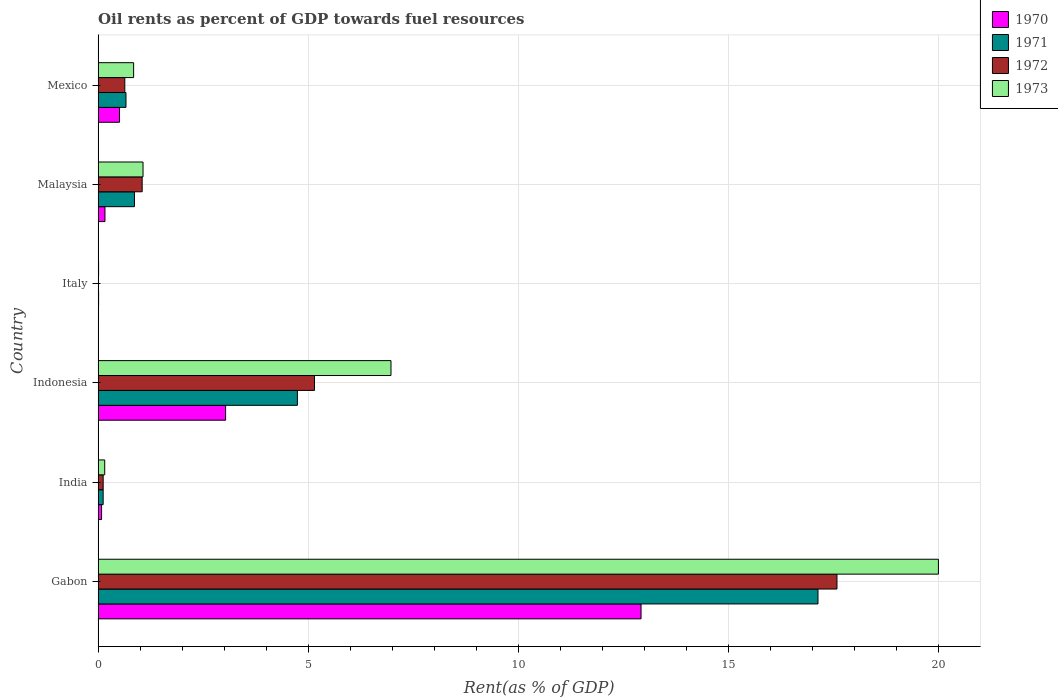How many different coloured bars are there?
Offer a terse response. 4. How many bars are there on the 3rd tick from the top?
Your response must be concise. 4. What is the oil rent in 1971 in India?
Your answer should be compact. 0.12. Across all countries, what is the maximum oil rent in 1970?
Give a very brief answer. 12.92. Across all countries, what is the minimum oil rent in 1970?
Make the answer very short. 0.01. In which country was the oil rent in 1972 maximum?
Provide a succinct answer. Gabon. In which country was the oil rent in 1971 minimum?
Your response must be concise. Italy. What is the total oil rent in 1973 in the graph?
Your answer should be very brief. 29.04. What is the difference between the oil rent in 1970 in India and that in Malaysia?
Give a very brief answer. -0.08. What is the difference between the oil rent in 1970 in Mexico and the oil rent in 1973 in Indonesia?
Ensure brevity in your answer.  -6.46. What is the average oil rent in 1973 per country?
Provide a succinct answer. 4.84. What is the difference between the oil rent in 1973 and oil rent in 1971 in Italy?
Your answer should be very brief. -0. What is the ratio of the oil rent in 1970 in Italy to that in Mexico?
Make the answer very short. 0.02. Is the oil rent in 1970 in Indonesia less than that in Malaysia?
Your response must be concise. No. What is the difference between the highest and the second highest oil rent in 1973?
Offer a very short reply. 13.03. What is the difference between the highest and the lowest oil rent in 1971?
Ensure brevity in your answer.  17.12. How many bars are there?
Give a very brief answer. 24. Are all the bars in the graph horizontal?
Provide a succinct answer. Yes. How many countries are there in the graph?
Make the answer very short. 6. Are the values on the major ticks of X-axis written in scientific E-notation?
Provide a short and direct response. No. Does the graph contain any zero values?
Give a very brief answer. No. Does the graph contain grids?
Offer a terse response. Yes. Where does the legend appear in the graph?
Provide a succinct answer. Top right. How many legend labels are there?
Provide a short and direct response. 4. What is the title of the graph?
Offer a terse response. Oil rents as percent of GDP towards fuel resources. Does "1977" appear as one of the legend labels in the graph?
Ensure brevity in your answer.  No. What is the label or title of the X-axis?
Your response must be concise. Rent(as % of GDP). What is the label or title of the Y-axis?
Give a very brief answer. Country. What is the Rent(as % of GDP) of 1970 in Gabon?
Your response must be concise. 12.92. What is the Rent(as % of GDP) in 1971 in Gabon?
Give a very brief answer. 17.13. What is the Rent(as % of GDP) of 1972 in Gabon?
Provide a succinct answer. 17.58. What is the Rent(as % of GDP) in 1973 in Gabon?
Provide a succinct answer. 19.99. What is the Rent(as % of GDP) in 1970 in India?
Offer a very short reply. 0.08. What is the Rent(as % of GDP) of 1971 in India?
Provide a short and direct response. 0.12. What is the Rent(as % of GDP) in 1972 in India?
Provide a succinct answer. 0.12. What is the Rent(as % of GDP) of 1973 in India?
Offer a terse response. 0.16. What is the Rent(as % of GDP) of 1970 in Indonesia?
Your answer should be very brief. 3.03. What is the Rent(as % of GDP) in 1971 in Indonesia?
Provide a short and direct response. 4.74. What is the Rent(as % of GDP) in 1972 in Indonesia?
Offer a terse response. 5.15. What is the Rent(as % of GDP) of 1973 in Indonesia?
Your response must be concise. 6.97. What is the Rent(as % of GDP) in 1970 in Italy?
Give a very brief answer. 0.01. What is the Rent(as % of GDP) of 1971 in Italy?
Your answer should be compact. 0.01. What is the Rent(as % of GDP) in 1972 in Italy?
Your response must be concise. 0.01. What is the Rent(as % of GDP) in 1973 in Italy?
Offer a terse response. 0.01. What is the Rent(as % of GDP) of 1970 in Malaysia?
Your answer should be very brief. 0.16. What is the Rent(as % of GDP) in 1971 in Malaysia?
Make the answer very short. 0.86. What is the Rent(as % of GDP) in 1972 in Malaysia?
Offer a very short reply. 1.05. What is the Rent(as % of GDP) of 1973 in Malaysia?
Your answer should be very brief. 1.07. What is the Rent(as % of GDP) of 1970 in Mexico?
Ensure brevity in your answer.  0.51. What is the Rent(as % of GDP) in 1971 in Mexico?
Your response must be concise. 0.66. What is the Rent(as % of GDP) in 1972 in Mexico?
Your answer should be compact. 0.63. What is the Rent(as % of GDP) in 1973 in Mexico?
Offer a very short reply. 0.84. Across all countries, what is the maximum Rent(as % of GDP) in 1970?
Provide a short and direct response. 12.92. Across all countries, what is the maximum Rent(as % of GDP) in 1971?
Make the answer very short. 17.13. Across all countries, what is the maximum Rent(as % of GDP) of 1972?
Keep it short and to the point. 17.58. Across all countries, what is the maximum Rent(as % of GDP) of 1973?
Offer a very short reply. 19.99. Across all countries, what is the minimum Rent(as % of GDP) of 1970?
Your answer should be very brief. 0.01. Across all countries, what is the minimum Rent(as % of GDP) in 1971?
Offer a very short reply. 0.01. Across all countries, what is the minimum Rent(as % of GDP) of 1972?
Provide a succinct answer. 0.01. Across all countries, what is the minimum Rent(as % of GDP) of 1973?
Your answer should be very brief. 0.01. What is the total Rent(as % of GDP) of 1970 in the graph?
Ensure brevity in your answer.  16.72. What is the total Rent(as % of GDP) of 1971 in the graph?
Offer a very short reply. 23.53. What is the total Rent(as % of GDP) of 1972 in the graph?
Your answer should be compact. 24.54. What is the total Rent(as % of GDP) in 1973 in the graph?
Provide a succinct answer. 29.04. What is the difference between the Rent(as % of GDP) of 1970 in Gabon and that in India?
Your answer should be compact. 12.84. What is the difference between the Rent(as % of GDP) in 1971 in Gabon and that in India?
Ensure brevity in your answer.  17.01. What is the difference between the Rent(as % of GDP) of 1972 in Gabon and that in India?
Provide a short and direct response. 17.46. What is the difference between the Rent(as % of GDP) in 1973 in Gabon and that in India?
Provide a succinct answer. 19.84. What is the difference between the Rent(as % of GDP) in 1970 in Gabon and that in Indonesia?
Offer a terse response. 9.88. What is the difference between the Rent(as % of GDP) in 1971 in Gabon and that in Indonesia?
Give a very brief answer. 12.39. What is the difference between the Rent(as % of GDP) in 1972 in Gabon and that in Indonesia?
Ensure brevity in your answer.  12.43. What is the difference between the Rent(as % of GDP) of 1973 in Gabon and that in Indonesia?
Your answer should be compact. 13.03. What is the difference between the Rent(as % of GDP) of 1970 in Gabon and that in Italy?
Your answer should be compact. 12.91. What is the difference between the Rent(as % of GDP) in 1971 in Gabon and that in Italy?
Make the answer very short. 17.12. What is the difference between the Rent(as % of GDP) of 1972 in Gabon and that in Italy?
Your answer should be compact. 17.57. What is the difference between the Rent(as % of GDP) of 1973 in Gabon and that in Italy?
Your response must be concise. 19.98. What is the difference between the Rent(as % of GDP) in 1970 in Gabon and that in Malaysia?
Your response must be concise. 12.76. What is the difference between the Rent(as % of GDP) of 1971 in Gabon and that in Malaysia?
Your answer should be very brief. 16.26. What is the difference between the Rent(as % of GDP) in 1972 in Gabon and that in Malaysia?
Provide a succinct answer. 16.53. What is the difference between the Rent(as % of GDP) in 1973 in Gabon and that in Malaysia?
Offer a very short reply. 18.92. What is the difference between the Rent(as % of GDP) of 1970 in Gabon and that in Mexico?
Make the answer very short. 12.41. What is the difference between the Rent(as % of GDP) in 1971 in Gabon and that in Mexico?
Provide a succinct answer. 16.47. What is the difference between the Rent(as % of GDP) in 1972 in Gabon and that in Mexico?
Keep it short and to the point. 16.95. What is the difference between the Rent(as % of GDP) of 1973 in Gabon and that in Mexico?
Give a very brief answer. 19.15. What is the difference between the Rent(as % of GDP) of 1970 in India and that in Indonesia?
Your answer should be very brief. -2.95. What is the difference between the Rent(as % of GDP) in 1971 in India and that in Indonesia?
Your answer should be compact. -4.62. What is the difference between the Rent(as % of GDP) in 1972 in India and that in Indonesia?
Your answer should be very brief. -5.03. What is the difference between the Rent(as % of GDP) in 1973 in India and that in Indonesia?
Keep it short and to the point. -6.81. What is the difference between the Rent(as % of GDP) in 1970 in India and that in Italy?
Provide a succinct answer. 0.07. What is the difference between the Rent(as % of GDP) in 1971 in India and that in Italy?
Ensure brevity in your answer.  0.11. What is the difference between the Rent(as % of GDP) in 1972 in India and that in Italy?
Your answer should be very brief. 0.11. What is the difference between the Rent(as % of GDP) in 1973 in India and that in Italy?
Offer a very short reply. 0.15. What is the difference between the Rent(as % of GDP) of 1970 in India and that in Malaysia?
Your answer should be very brief. -0.08. What is the difference between the Rent(as % of GDP) of 1971 in India and that in Malaysia?
Make the answer very short. -0.74. What is the difference between the Rent(as % of GDP) of 1972 in India and that in Malaysia?
Offer a very short reply. -0.93. What is the difference between the Rent(as % of GDP) in 1973 in India and that in Malaysia?
Keep it short and to the point. -0.91. What is the difference between the Rent(as % of GDP) in 1970 in India and that in Mexico?
Keep it short and to the point. -0.43. What is the difference between the Rent(as % of GDP) in 1971 in India and that in Mexico?
Keep it short and to the point. -0.54. What is the difference between the Rent(as % of GDP) of 1972 in India and that in Mexico?
Your answer should be very brief. -0.51. What is the difference between the Rent(as % of GDP) of 1973 in India and that in Mexico?
Make the answer very short. -0.69. What is the difference between the Rent(as % of GDP) of 1970 in Indonesia and that in Italy?
Give a very brief answer. 3.02. What is the difference between the Rent(as % of GDP) of 1971 in Indonesia and that in Italy?
Offer a very short reply. 4.73. What is the difference between the Rent(as % of GDP) in 1972 in Indonesia and that in Italy?
Provide a succinct answer. 5.14. What is the difference between the Rent(as % of GDP) of 1973 in Indonesia and that in Italy?
Provide a short and direct response. 6.96. What is the difference between the Rent(as % of GDP) in 1970 in Indonesia and that in Malaysia?
Ensure brevity in your answer.  2.87. What is the difference between the Rent(as % of GDP) in 1971 in Indonesia and that in Malaysia?
Your answer should be compact. 3.88. What is the difference between the Rent(as % of GDP) in 1972 in Indonesia and that in Malaysia?
Keep it short and to the point. 4.1. What is the difference between the Rent(as % of GDP) of 1973 in Indonesia and that in Malaysia?
Give a very brief answer. 5.9. What is the difference between the Rent(as % of GDP) of 1970 in Indonesia and that in Mexico?
Offer a very short reply. 2.52. What is the difference between the Rent(as % of GDP) in 1971 in Indonesia and that in Mexico?
Give a very brief answer. 4.08. What is the difference between the Rent(as % of GDP) in 1972 in Indonesia and that in Mexico?
Make the answer very short. 4.51. What is the difference between the Rent(as % of GDP) in 1973 in Indonesia and that in Mexico?
Make the answer very short. 6.12. What is the difference between the Rent(as % of GDP) in 1970 in Italy and that in Malaysia?
Your answer should be compact. -0.15. What is the difference between the Rent(as % of GDP) in 1971 in Italy and that in Malaysia?
Your response must be concise. -0.85. What is the difference between the Rent(as % of GDP) in 1972 in Italy and that in Malaysia?
Give a very brief answer. -1.04. What is the difference between the Rent(as % of GDP) in 1973 in Italy and that in Malaysia?
Offer a terse response. -1.06. What is the difference between the Rent(as % of GDP) of 1970 in Italy and that in Mexico?
Provide a short and direct response. -0.5. What is the difference between the Rent(as % of GDP) in 1971 in Italy and that in Mexico?
Provide a short and direct response. -0.65. What is the difference between the Rent(as % of GDP) of 1972 in Italy and that in Mexico?
Ensure brevity in your answer.  -0.63. What is the difference between the Rent(as % of GDP) of 1973 in Italy and that in Mexico?
Ensure brevity in your answer.  -0.83. What is the difference between the Rent(as % of GDP) of 1970 in Malaysia and that in Mexico?
Provide a succinct answer. -0.35. What is the difference between the Rent(as % of GDP) in 1971 in Malaysia and that in Mexico?
Keep it short and to the point. 0.2. What is the difference between the Rent(as % of GDP) in 1972 in Malaysia and that in Mexico?
Ensure brevity in your answer.  0.41. What is the difference between the Rent(as % of GDP) in 1973 in Malaysia and that in Mexico?
Ensure brevity in your answer.  0.22. What is the difference between the Rent(as % of GDP) of 1970 in Gabon and the Rent(as % of GDP) of 1971 in India?
Offer a very short reply. 12.8. What is the difference between the Rent(as % of GDP) in 1970 in Gabon and the Rent(as % of GDP) in 1972 in India?
Your answer should be compact. 12.8. What is the difference between the Rent(as % of GDP) of 1970 in Gabon and the Rent(as % of GDP) of 1973 in India?
Keep it short and to the point. 12.76. What is the difference between the Rent(as % of GDP) of 1971 in Gabon and the Rent(as % of GDP) of 1972 in India?
Provide a succinct answer. 17.01. What is the difference between the Rent(as % of GDP) of 1971 in Gabon and the Rent(as % of GDP) of 1973 in India?
Keep it short and to the point. 16.97. What is the difference between the Rent(as % of GDP) of 1972 in Gabon and the Rent(as % of GDP) of 1973 in India?
Your response must be concise. 17.42. What is the difference between the Rent(as % of GDP) of 1970 in Gabon and the Rent(as % of GDP) of 1971 in Indonesia?
Provide a succinct answer. 8.18. What is the difference between the Rent(as % of GDP) in 1970 in Gabon and the Rent(as % of GDP) in 1972 in Indonesia?
Make the answer very short. 7.77. What is the difference between the Rent(as % of GDP) of 1970 in Gabon and the Rent(as % of GDP) of 1973 in Indonesia?
Your answer should be very brief. 5.95. What is the difference between the Rent(as % of GDP) in 1971 in Gabon and the Rent(as % of GDP) in 1972 in Indonesia?
Provide a succinct answer. 11.98. What is the difference between the Rent(as % of GDP) of 1971 in Gabon and the Rent(as % of GDP) of 1973 in Indonesia?
Provide a short and direct response. 10.16. What is the difference between the Rent(as % of GDP) of 1972 in Gabon and the Rent(as % of GDP) of 1973 in Indonesia?
Your response must be concise. 10.61. What is the difference between the Rent(as % of GDP) of 1970 in Gabon and the Rent(as % of GDP) of 1971 in Italy?
Offer a terse response. 12.91. What is the difference between the Rent(as % of GDP) of 1970 in Gabon and the Rent(as % of GDP) of 1972 in Italy?
Your response must be concise. 12.91. What is the difference between the Rent(as % of GDP) in 1970 in Gabon and the Rent(as % of GDP) in 1973 in Italy?
Ensure brevity in your answer.  12.91. What is the difference between the Rent(as % of GDP) of 1971 in Gabon and the Rent(as % of GDP) of 1972 in Italy?
Provide a succinct answer. 17.12. What is the difference between the Rent(as % of GDP) of 1971 in Gabon and the Rent(as % of GDP) of 1973 in Italy?
Your response must be concise. 17.12. What is the difference between the Rent(as % of GDP) of 1972 in Gabon and the Rent(as % of GDP) of 1973 in Italy?
Your answer should be compact. 17.57. What is the difference between the Rent(as % of GDP) of 1970 in Gabon and the Rent(as % of GDP) of 1971 in Malaysia?
Your answer should be compact. 12.05. What is the difference between the Rent(as % of GDP) in 1970 in Gabon and the Rent(as % of GDP) in 1972 in Malaysia?
Your answer should be compact. 11.87. What is the difference between the Rent(as % of GDP) in 1970 in Gabon and the Rent(as % of GDP) in 1973 in Malaysia?
Your answer should be compact. 11.85. What is the difference between the Rent(as % of GDP) in 1971 in Gabon and the Rent(as % of GDP) in 1972 in Malaysia?
Make the answer very short. 16.08. What is the difference between the Rent(as % of GDP) of 1971 in Gabon and the Rent(as % of GDP) of 1973 in Malaysia?
Your answer should be compact. 16.06. What is the difference between the Rent(as % of GDP) in 1972 in Gabon and the Rent(as % of GDP) in 1973 in Malaysia?
Provide a succinct answer. 16.51. What is the difference between the Rent(as % of GDP) of 1970 in Gabon and the Rent(as % of GDP) of 1971 in Mexico?
Make the answer very short. 12.26. What is the difference between the Rent(as % of GDP) of 1970 in Gabon and the Rent(as % of GDP) of 1972 in Mexico?
Your response must be concise. 12.28. What is the difference between the Rent(as % of GDP) in 1970 in Gabon and the Rent(as % of GDP) in 1973 in Mexico?
Your response must be concise. 12.07. What is the difference between the Rent(as % of GDP) in 1971 in Gabon and the Rent(as % of GDP) in 1972 in Mexico?
Keep it short and to the point. 16.49. What is the difference between the Rent(as % of GDP) in 1971 in Gabon and the Rent(as % of GDP) in 1973 in Mexico?
Offer a terse response. 16.28. What is the difference between the Rent(as % of GDP) of 1972 in Gabon and the Rent(as % of GDP) of 1973 in Mexico?
Provide a succinct answer. 16.74. What is the difference between the Rent(as % of GDP) of 1970 in India and the Rent(as % of GDP) of 1971 in Indonesia?
Make the answer very short. -4.66. What is the difference between the Rent(as % of GDP) in 1970 in India and the Rent(as % of GDP) in 1972 in Indonesia?
Offer a terse response. -5.07. What is the difference between the Rent(as % of GDP) in 1970 in India and the Rent(as % of GDP) in 1973 in Indonesia?
Your response must be concise. -6.89. What is the difference between the Rent(as % of GDP) of 1971 in India and the Rent(as % of GDP) of 1972 in Indonesia?
Provide a succinct answer. -5.03. What is the difference between the Rent(as % of GDP) in 1971 in India and the Rent(as % of GDP) in 1973 in Indonesia?
Your response must be concise. -6.85. What is the difference between the Rent(as % of GDP) in 1972 in India and the Rent(as % of GDP) in 1973 in Indonesia?
Offer a terse response. -6.85. What is the difference between the Rent(as % of GDP) in 1970 in India and the Rent(as % of GDP) in 1971 in Italy?
Provide a short and direct response. 0.07. What is the difference between the Rent(as % of GDP) of 1970 in India and the Rent(as % of GDP) of 1972 in Italy?
Offer a terse response. 0.07. What is the difference between the Rent(as % of GDP) in 1970 in India and the Rent(as % of GDP) in 1973 in Italy?
Provide a succinct answer. 0.07. What is the difference between the Rent(as % of GDP) of 1971 in India and the Rent(as % of GDP) of 1972 in Italy?
Ensure brevity in your answer.  0.11. What is the difference between the Rent(as % of GDP) in 1971 in India and the Rent(as % of GDP) in 1973 in Italy?
Your answer should be compact. 0.11. What is the difference between the Rent(as % of GDP) of 1972 in India and the Rent(as % of GDP) of 1973 in Italy?
Offer a very short reply. 0.11. What is the difference between the Rent(as % of GDP) of 1970 in India and the Rent(as % of GDP) of 1971 in Malaysia?
Your answer should be compact. -0.78. What is the difference between the Rent(as % of GDP) in 1970 in India and the Rent(as % of GDP) in 1972 in Malaysia?
Offer a very short reply. -0.97. What is the difference between the Rent(as % of GDP) of 1970 in India and the Rent(as % of GDP) of 1973 in Malaysia?
Give a very brief answer. -0.99. What is the difference between the Rent(as % of GDP) of 1971 in India and the Rent(as % of GDP) of 1972 in Malaysia?
Give a very brief answer. -0.93. What is the difference between the Rent(as % of GDP) of 1971 in India and the Rent(as % of GDP) of 1973 in Malaysia?
Keep it short and to the point. -0.95. What is the difference between the Rent(as % of GDP) of 1972 in India and the Rent(as % of GDP) of 1973 in Malaysia?
Provide a succinct answer. -0.95. What is the difference between the Rent(as % of GDP) in 1970 in India and the Rent(as % of GDP) in 1971 in Mexico?
Your answer should be very brief. -0.58. What is the difference between the Rent(as % of GDP) in 1970 in India and the Rent(as % of GDP) in 1972 in Mexico?
Offer a very short reply. -0.55. What is the difference between the Rent(as % of GDP) in 1970 in India and the Rent(as % of GDP) in 1973 in Mexico?
Provide a succinct answer. -0.76. What is the difference between the Rent(as % of GDP) in 1971 in India and the Rent(as % of GDP) in 1972 in Mexico?
Give a very brief answer. -0.51. What is the difference between the Rent(as % of GDP) of 1971 in India and the Rent(as % of GDP) of 1973 in Mexico?
Ensure brevity in your answer.  -0.72. What is the difference between the Rent(as % of GDP) of 1972 in India and the Rent(as % of GDP) of 1973 in Mexico?
Your answer should be very brief. -0.72. What is the difference between the Rent(as % of GDP) in 1970 in Indonesia and the Rent(as % of GDP) in 1971 in Italy?
Your answer should be very brief. 3.02. What is the difference between the Rent(as % of GDP) of 1970 in Indonesia and the Rent(as % of GDP) of 1972 in Italy?
Your answer should be very brief. 3.02. What is the difference between the Rent(as % of GDP) in 1970 in Indonesia and the Rent(as % of GDP) in 1973 in Italy?
Provide a succinct answer. 3.02. What is the difference between the Rent(as % of GDP) of 1971 in Indonesia and the Rent(as % of GDP) of 1972 in Italy?
Offer a terse response. 4.73. What is the difference between the Rent(as % of GDP) of 1971 in Indonesia and the Rent(as % of GDP) of 1973 in Italy?
Offer a terse response. 4.73. What is the difference between the Rent(as % of GDP) in 1972 in Indonesia and the Rent(as % of GDP) in 1973 in Italy?
Provide a short and direct response. 5.14. What is the difference between the Rent(as % of GDP) of 1970 in Indonesia and the Rent(as % of GDP) of 1971 in Malaysia?
Offer a very short reply. 2.17. What is the difference between the Rent(as % of GDP) of 1970 in Indonesia and the Rent(as % of GDP) of 1972 in Malaysia?
Your response must be concise. 1.99. What is the difference between the Rent(as % of GDP) in 1970 in Indonesia and the Rent(as % of GDP) in 1973 in Malaysia?
Provide a succinct answer. 1.96. What is the difference between the Rent(as % of GDP) in 1971 in Indonesia and the Rent(as % of GDP) in 1972 in Malaysia?
Your answer should be very brief. 3.69. What is the difference between the Rent(as % of GDP) of 1971 in Indonesia and the Rent(as % of GDP) of 1973 in Malaysia?
Your response must be concise. 3.67. What is the difference between the Rent(as % of GDP) of 1972 in Indonesia and the Rent(as % of GDP) of 1973 in Malaysia?
Make the answer very short. 4.08. What is the difference between the Rent(as % of GDP) in 1970 in Indonesia and the Rent(as % of GDP) in 1971 in Mexico?
Your answer should be compact. 2.37. What is the difference between the Rent(as % of GDP) of 1970 in Indonesia and the Rent(as % of GDP) of 1972 in Mexico?
Your answer should be very brief. 2.4. What is the difference between the Rent(as % of GDP) in 1970 in Indonesia and the Rent(as % of GDP) in 1973 in Mexico?
Your answer should be very brief. 2.19. What is the difference between the Rent(as % of GDP) of 1971 in Indonesia and the Rent(as % of GDP) of 1972 in Mexico?
Provide a short and direct response. 4.11. What is the difference between the Rent(as % of GDP) of 1971 in Indonesia and the Rent(as % of GDP) of 1973 in Mexico?
Make the answer very short. 3.9. What is the difference between the Rent(as % of GDP) in 1972 in Indonesia and the Rent(as % of GDP) in 1973 in Mexico?
Make the answer very short. 4.3. What is the difference between the Rent(as % of GDP) in 1970 in Italy and the Rent(as % of GDP) in 1971 in Malaysia?
Keep it short and to the point. -0.85. What is the difference between the Rent(as % of GDP) of 1970 in Italy and the Rent(as % of GDP) of 1972 in Malaysia?
Offer a very short reply. -1.04. What is the difference between the Rent(as % of GDP) in 1970 in Italy and the Rent(as % of GDP) in 1973 in Malaysia?
Offer a terse response. -1.06. What is the difference between the Rent(as % of GDP) in 1971 in Italy and the Rent(as % of GDP) in 1972 in Malaysia?
Keep it short and to the point. -1.04. What is the difference between the Rent(as % of GDP) of 1971 in Italy and the Rent(as % of GDP) of 1973 in Malaysia?
Give a very brief answer. -1.06. What is the difference between the Rent(as % of GDP) in 1972 in Italy and the Rent(as % of GDP) in 1973 in Malaysia?
Your answer should be compact. -1.06. What is the difference between the Rent(as % of GDP) of 1970 in Italy and the Rent(as % of GDP) of 1971 in Mexico?
Offer a very short reply. -0.65. What is the difference between the Rent(as % of GDP) of 1970 in Italy and the Rent(as % of GDP) of 1972 in Mexico?
Your response must be concise. -0.62. What is the difference between the Rent(as % of GDP) of 1970 in Italy and the Rent(as % of GDP) of 1973 in Mexico?
Ensure brevity in your answer.  -0.83. What is the difference between the Rent(as % of GDP) of 1971 in Italy and the Rent(as % of GDP) of 1972 in Mexico?
Ensure brevity in your answer.  -0.62. What is the difference between the Rent(as % of GDP) of 1971 in Italy and the Rent(as % of GDP) of 1973 in Mexico?
Your answer should be compact. -0.83. What is the difference between the Rent(as % of GDP) in 1972 in Italy and the Rent(as % of GDP) in 1973 in Mexico?
Your answer should be compact. -0.84. What is the difference between the Rent(as % of GDP) of 1970 in Malaysia and the Rent(as % of GDP) of 1971 in Mexico?
Offer a very short reply. -0.5. What is the difference between the Rent(as % of GDP) in 1970 in Malaysia and the Rent(as % of GDP) in 1972 in Mexico?
Offer a very short reply. -0.47. What is the difference between the Rent(as % of GDP) in 1970 in Malaysia and the Rent(as % of GDP) in 1973 in Mexico?
Keep it short and to the point. -0.68. What is the difference between the Rent(as % of GDP) of 1971 in Malaysia and the Rent(as % of GDP) of 1972 in Mexico?
Offer a very short reply. 0.23. What is the difference between the Rent(as % of GDP) in 1971 in Malaysia and the Rent(as % of GDP) in 1973 in Mexico?
Make the answer very short. 0.02. What is the difference between the Rent(as % of GDP) of 1972 in Malaysia and the Rent(as % of GDP) of 1973 in Mexico?
Offer a very short reply. 0.2. What is the average Rent(as % of GDP) of 1970 per country?
Offer a very short reply. 2.79. What is the average Rent(as % of GDP) of 1971 per country?
Ensure brevity in your answer.  3.92. What is the average Rent(as % of GDP) in 1972 per country?
Give a very brief answer. 4.09. What is the average Rent(as % of GDP) of 1973 per country?
Make the answer very short. 4.84. What is the difference between the Rent(as % of GDP) of 1970 and Rent(as % of GDP) of 1971 in Gabon?
Your response must be concise. -4.21. What is the difference between the Rent(as % of GDP) in 1970 and Rent(as % of GDP) in 1972 in Gabon?
Offer a very short reply. -4.66. What is the difference between the Rent(as % of GDP) in 1970 and Rent(as % of GDP) in 1973 in Gabon?
Offer a very short reply. -7.08. What is the difference between the Rent(as % of GDP) of 1971 and Rent(as % of GDP) of 1972 in Gabon?
Give a very brief answer. -0.45. What is the difference between the Rent(as % of GDP) of 1971 and Rent(as % of GDP) of 1973 in Gabon?
Provide a succinct answer. -2.87. What is the difference between the Rent(as % of GDP) in 1972 and Rent(as % of GDP) in 1973 in Gabon?
Provide a succinct answer. -2.41. What is the difference between the Rent(as % of GDP) in 1970 and Rent(as % of GDP) in 1971 in India?
Provide a succinct answer. -0.04. What is the difference between the Rent(as % of GDP) in 1970 and Rent(as % of GDP) in 1972 in India?
Your response must be concise. -0.04. What is the difference between the Rent(as % of GDP) of 1970 and Rent(as % of GDP) of 1973 in India?
Offer a terse response. -0.07. What is the difference between the Rent(as % of GDP) in 1971 and Rent(as % of GDP) in 1972 in India?
Provide a succinct answer. -0. What is the difference between the Rent(as % of GDP) in 1971 and Rent(as % of GDP) in 1973 in India?
Give a very brief answer. -0.04. What is the difference between the Rent(as % of GDP) in 1972 and Rent(as % of GDP) in 1973 in India?
Make the answer very short. -0.04. What is the difference between the Rent(as % of GDP) in 1970 and Rent(as % of GDP) in 1971 in Indonesia?
Your answer should be compact. -1.71. What is the difference between the Rent(as % of GDP) in 1970 and Rent(as % of GDP) in 1972 in Indonesia?
Your response must be concise. -2.11. What is the difference between the Rent(as % of GDP) of 1970 and Rent(as % of GDP) of 1973 in Indonesia?
Ensure brevity in your answer.  -3.93. What is the difference between the Rent(as % of GDP) in 1971 and Rent(as % of GDP) in 1972 in Indonesia?
Offer a very short reply. -0.41. What is the difference between the Rent(as % of GDP) in 1971 and Rent(as % of GDP) in 1973 in Indonesia?
Give a very brief answer. -2.23. What is the difference between the Rent(as % of GDP) of 1972 and Rent(as % of GDP) of 1973 in Indonesia?
Provide a succinct answer. -1.82. What is the difference between the Rent(as % of GDP) in 1970 and Rent(as % of GDP) in 1971 in Italy?
Offer a terse response. -0. What is the difference between the Rent(as % of GDP) in 1970 and Rent(as % of GDP) in 1972 in Italy?
Provide a succinct answer. 0. What is the difference between the Rent(as % of GDP) in 1970 and Rent(as % of GDP) in 1973 in Italy?
Offer a very short reply. -0. What is the difference between the Rent(as % of GDP) of 1971 and Rent(as % of GDP) of 1972 in Italy?
Offer a very short reply. 0. What is the difference between the Rent(as % of GDP) of 1971 and Rent(as % of GDP) of 1973 in Italy?
Offer a very short reply. 0. What is the difference between the Rent(as % of GDP) of 1972 and Rent(as % of GDP) of 1973 in Italy?
Keep it short and to the point. -0. What is the difference between the Rent(as % of GDP) of 1970 and Rent(as % of GDP) of 1971 in Malaysia?
Keep it short and to the point. -0.7. What is the difference between the Rent(as % of GDP) in 1970 and Rent(as % of GDP) in 1972 in Malaysia?
Keep it short and to the point. -0.89. What is the difference between the Rent(as % of GDP) in 1970 and Rent(as % of GDP) in 1973 in Malaysia?
Provide a short and direct response. -0.91. What is the difference between the Rent(as % of GDP) in 1971 and Rent(as % of GDP) in 1972 in Malaysia?
Your answer should be compact. -0.18. What is the difference between the Rent(as % of GDP) of 1971 and Rent(as % of GDP) of 1973 in Malaysia?
Provide a succinct answer. -0.2. What is the difference between the Rent(as % of GDP) in 1972 and Rent(as % of GDP) in 1973 in Malaysia?
Make the answer very short. -0.02. What is the difference between the Rent(as % of GDP) of 1970 and Rent(as % of GDP) of 1971 in Mexico?
Keep it short and to the point. -0.15. What is the difference between the Rent(as % of GDP) in 1970 and Rent(as % of GDP) in 1972 in Mexico?
Your answer should be very brief. -0.13. What is the difference between the Rent(as % of GDP) of 1970 and Rent(as % of GDP) of 1973 in Mexico?
Ensure brevity in your answer.  -0.34. What is the difference between the Rent(as % of GDP) of 1971 and Rent(as % of GDP) of 1972 in Mexico?
Make the answer very short. 0.03. What is the difference between the Rent(as % of GDP) of 1971 and Rent(as % of GDP) of 1973 in Mexico?
Provide a succinct answer. -0.18. What is the difference between the Rent(as % of GDP) of 1972 and Rent(as % of GDP) of 1973 in Mexico?
Your response must be concise. -0.21. What is the ratio of the Rent(as % of GDP) of 1970 in Gabon to that in India?
Keep it short and to the point. 156.62. What is the ratio of the Rent(as % of GDP) of 1971 in Gabon to that in India?
Keep it short and to the point. 142.99. What is the ratio of the Rent(as % of GDP) of 1972 in Gabon to that in India?
Your answer should be very brief. 146.29. What is the ratio of the Rent(as % of GDP) in 1973 in Gabon to that in India?
Give a very brief answer. 127.16. What is the ratio of the Rent(as % of GDP) in 1970 in Gabon to that in Indonesia?
Provide a succinct answer. 4.26. What is the ratio of the Rent(as % of GDP) of 1971 in Gabon to that in Indonesia?
Ensure brevity in your answer.  3.61. What is the ratio of the Rent(as % of GDP) in 1972 in Gabon to that in Indonesia?
Make the answer very short. 3.41. What is the ratio of the Rent(as % of GDP) in 1973 in Gabon to that in Indonesia?
Offer a terse response. 2.87. What is the ratio of the Rent(as % of GDP) of 1970 in Gabon to that in Italy?
Keep it short and to the point. 1310.76. What is the ratio of the Rent(as % of GDP) of 1971 in Gabon to that in Italy?
Ensure brevity in your answer.  1461.71. What is the ratio of the Rent(as % of GDP) of 1972 in Gabon to that in Italy?
Provide a succinct answer. 1889.75. What is the ratio of the Rent(as % of GDP) in 1973 in Gabon to that in Italy?
Give a very brief answer. 1784.8. What is the ratio of the Rent(as % of GDP) in 1970 in Gabon to that in Malaysia?
Provide a succinct answer. 79.24. What is the ratio of the Rent(as % of GDP) of 1971 in Gabon to that in Malaysia?
Make the answer very short. 19.81. What is the ratio of the Rent(as % of GDP) in 1972 in Gabon to that in Malaysia?
Provide a succinct answer. 16.77. What is the ratio of the Rent(as % of GDP) in 1973 in Gabon to that in Malaysia?
Give a very brief answer. 18.71. What is the ratio of the Rent(as % of GDP) of 1970 in Gabon to that in Mexico?
Your response must be concise. 25.35. What is the ratio of the Rent(as % of GDP) in 1971 in Gabon to that in Mexico?
Your answer should be very brief. 25.84. What is the ratio of the Rent(as % of GDP) in 1972 in Gabon to that in Mexico?
Your answer should be very brief. 27.7. What is the ratio of the Rent(as % of GDP) of 1973 in Gabon to that in Mexico?
Provide a succinct answer. 23.67. What is the ratio of the Rent(as % of GDP) in 1970 in India to that in Indonesia?
Keep it short and to the point. 0.03. What is the ratio of the Rent(as % of GDP) in 1971 in India to that in Indonesia?
Give a very brief answer. 0.03. What is the ratio of the Rent(as % of GDP) of 1972 in India to that in Indonesia?
Provide a short and direct response. 0.02. What is the ratio of the Rent(as % of GDP) of 1973 in India to that in Indonesia?
Keep it short and to the point. 0.02. What is the ratio of the Rent(as % of GDP) of 1970 in India to that in Italy?
Make the answer very short. 8.37. What is the ratio of the Rent(as % of GDP) in 1971 in India to that in Italy?
Your response must be concise. 10.22. What is the ratio of the Rent(as % of GDP) of 1972 in India to that in Italy?
Provide a succinct answer. 12.92. What is the ratio of the Rent(as % of GDP) in 1973 in India to that in Italy?
Ensure brevity in your answer.  14.04. What is the ratio of the Rent(as % of GDP) in 1970 in India to that in Malaysia?
Your answer should be compact. 0.51. What is the ratio of the Rent(as % of GDP) of 1971 in India to that in Malaysia?
Give a very brief answer. 0.14. What is the ratio of the Rent(as % of GDP) of 1972 in India to that in Malaysia?
Offer a terse response. 0.11. What is the ratio of the Rent(as % of GDP) in 1973 in India to that in Malaysia?
Make the answer very short. 0.15. What is the ratio of the Rent(as % of GDP) of 1970 in India to that in Mexico?
Ensure brevity in your answer.  0.16. What is the ratio of the Rent(as % of GDP) in 1971 in India to that in Mexico?
Give a very brief answer. 0.18. What is the ratio of the Rent(as % of GDP) of 1972 in India to that in Mexico?
Ensure brevity in your answer.  0.19. What is the ratio of the Rent(as % of GDP) of 1973 in India to that in Mexico?
Ensure brevity in your answer.  0.19. What is the ratio of the Rent(as % of GDP) of 1970 in Indonesia to that in Italy?
Provide a succinct answer. 307.81. What is the ratio of the Rent(as % of GDP) in 1971 in Indonesia to that in Italy?
Your response must be concise. 404.61. What is the ratio of the Rent(as % of GDP) of 1972 in Indonesia to that in Italy?
Provide a short and direct response. 553.4. What is the ratio of the Rent(as % of GDP) of 1973 in Indonesia to that in Italy?
Make the answer very short. 622.04. What is the ratio of the Rent(as % of GDP) of 1970 in Indonesia to that in Malaysia?
Ensure brevity in your answer.  18.61. What is the ratio of the Rent(as % of GDP) of 1971 in Indonesia to that in Malaysia?
Your answer should be compact. 5.48. What is the ratio of the Rent(as % of GDP) of 1972 in Indonesia to that in Malaysia?
Provide a succinct answer. 4.91. What is the ratio of the Rent(as % of GDP) in 1973 in Indonesia to that in Malaysia?
Keep it short and to the point. 6.52. What is the ratio of the Rent(as % of GDP) of 1970 in Indonesia to that in Mexico?
Give a very brief answer. 5.95. What is the ratio of the Rent(as % of GDP) of 1971 in Indonesia to that in Mexico?
Your answer should be compact. 7.15. What is the ratio of the Rent(as % of GDP) of 1972 in Indonesia to that in Mexico?
Your answer should be very brief. 8.11. What is the ratio of the Rent(as % of GDP) of 1973 in Indonesia to that in Mexico?
Your answer should be compact. 8.25. What is the ratio of the Rent(as % of GDP) of 1970 in Italy to that in Malaysia?
Provide a succinct answer. 0.06. What is the ratio of the Rent(as % of GDP) of 1971 in Italy to that in Malaysia?
Provide a short and direct response. 0.01. What is the ratio of the Rent(as % of GDP) of 1972 in Italy to that in Malaysia?
Ensure brevity in your answer.  0.01. What is the ratio of the Rent(as % of GDP) of 1973 in Italy to that in Malaysia?
Your answer should be very brief. 0.01. What is the ratio of the Rent(as % of GDP) of 1970 in Italy to that in Mexico?
Provide a succinct answer. 0.02. What is the ratio of the Rent(as % of GDP) in 1971 in Italy to that in Mexico?
Your answer should be compact. 0.02. What is the ratio of the Rent(as % of GDP) in 1972 in Italy to that in Mexico?
Provide a succinct answer. 0.01. What is the ratio of the Rent(as % of GDP) in 1973 in Italy to that in Mexico?
Your answer should be very brief. 0.01. What is the ratio of the Rent(as % of GDP) of 1970 in Malaysia to that in Mexico?
Offer a very short reply. 0.32. What is the ratio of the Rent(as % of GDP) in 1971 in Malaysia to that in Mexico?
Offer a very short reply. 1.3. What is the ratio of the Rent(as % of GDP) in 1972 in Malaysia to that in Mexico?
Keep it short and to the point. 1.65. What is the ratio of the Rent(as % of GDP) of 1973 in Malaysia to that in Mexico?
Your answer should be compact. 1.27. What is the difference between the highest and the second highest Rent(as % of GDP) in 1970?
Provide a succinct answer. 9.88. What is the difference between the highest and the second highest Rent(as % of GDP) of 1971?
Make the answer very short. 12.39. What is the difference between the highest and the second highest Rent(as % of GDP) of 1972?
Provide a succinct answer. 12.43. What is the difference between the highest and the second highest Rent(as % of GDP) in 1973?
Provide a short and direct response. 13.03. What is the difference between the highest and the lowest Rent(as % of GDP) of 1970?
Provide a succinct answer. 12.91. What is the difference between the highest and the lowest Rent(as % of GDP) in 1971?
Offer a very short reply. 17.12. What is the difference between the highest and the lowest Rent(as % of GDP) of 1972?
Ensure brevity in your answer.  17.57. What is the difference between the highest and the lowest Rent(as % of GDP) of 1973?
Offer a terse response. 19.98. 